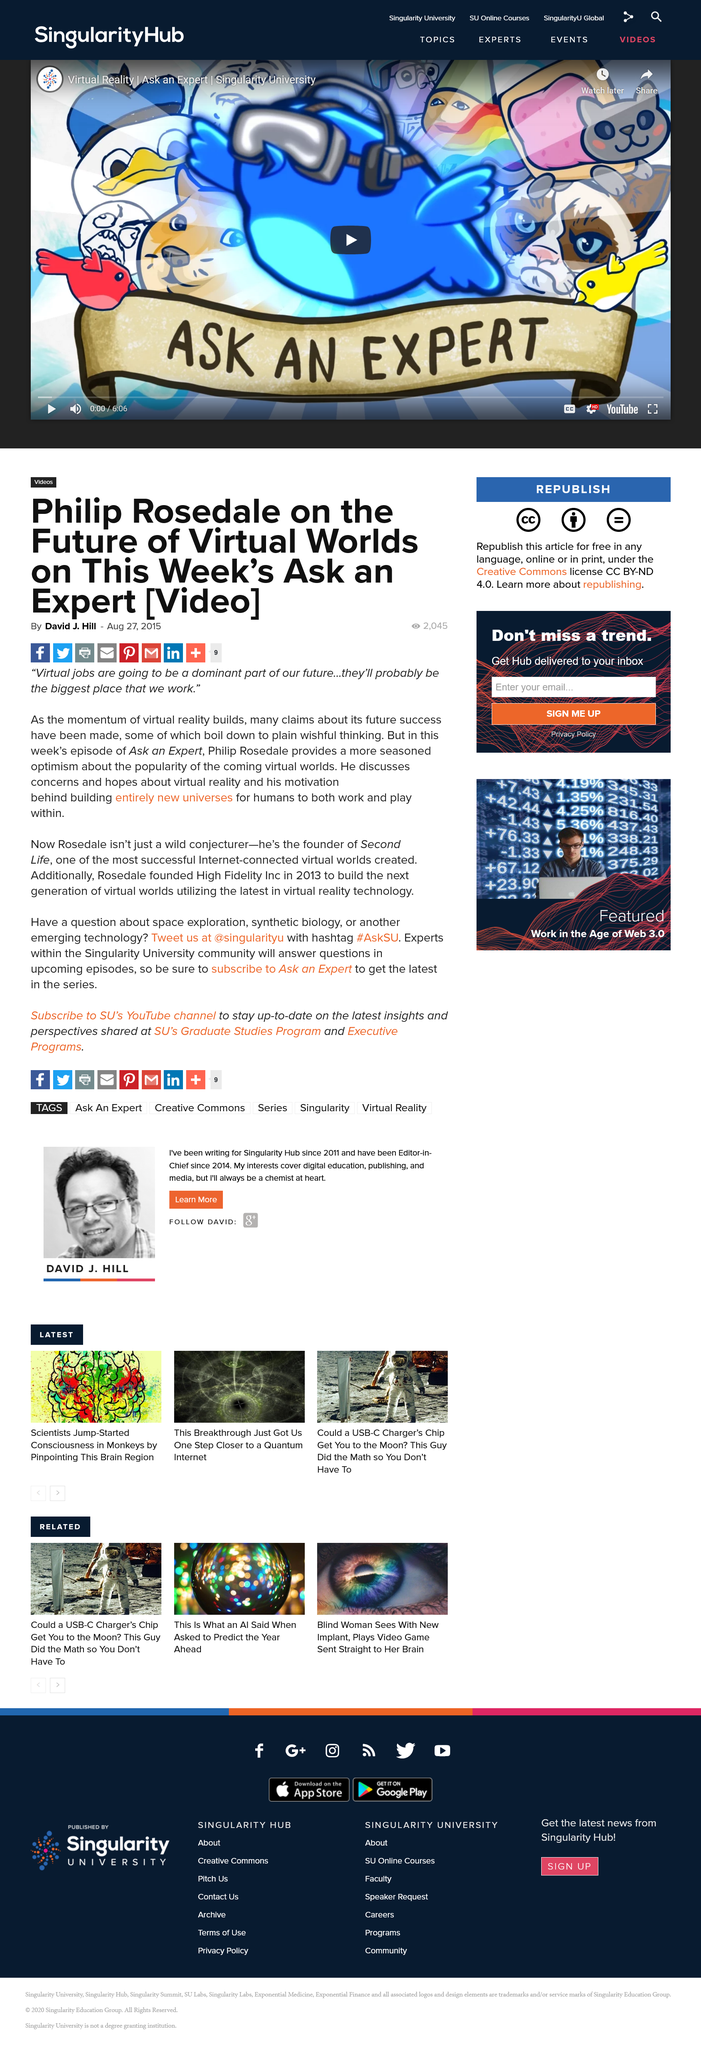Specify some key components in this picture. Philip Rosedale is the founder of Second Life. In 2013, Rosedale founded High Fidelity Inc. to build the next generation of virtual worlds. I, David J. Hill, wrote this article. 